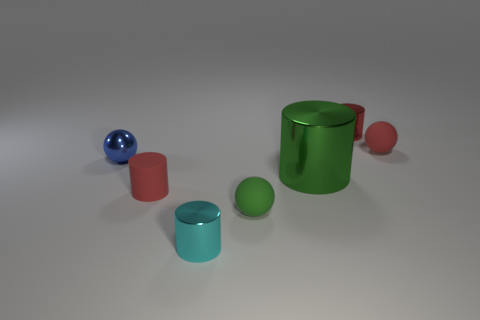Add 1 small green matte spheres. How many objects exist? 8 Subtract all big cylinders. How many cylinders are left? 3 Subtract 0 green blocks. How many objects are left? 7 Subtract all cylinders. How many objects are left? 3 Subtract 1 cylinders. How many cylinders are left? 3 Subtract all yellow spheres. Subtract all gray blocks. How many spheres are left? 3 Subtract all brown balls. How many green cylinders are left? 1 Subtract all tiny cylinders. Subtract all gray matte objects. How many objects are left? 4 Add 1 rubber spheres. How many rubber spheres are left? 3 Add 7 red shiny objects. How many red shiny objects exist? 8 